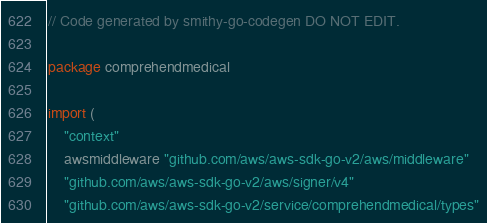<code> <loc_0><loc_0><loc_500><loc_500><_Go_>// Code generated by smithy-go-codegen DO NOT EDIT.

package comprehendmedical

import (
	"context"
	awsmiddleware "github.com/aws/aws-sdk-go-v2/aws/middleware"
	"github.com/aws/aws-sdk-go-v2/aws/signer/v4"
	"github.com/aws/aws-sdk-go-v2/service/comprehendmedical/types"</code> 